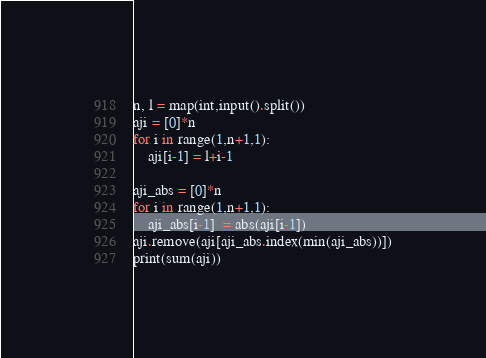Convert code to text. <code><loc_0><loc_0><loc_500><loc_500><_Python_>n, l = map(int,input().split())
aji = [0]*n
for i in range(1,n+1,1):
    aji[i-1] = l+i-1

aji_abs = [0]*n
for i in range(1,n+1,1):
    aji_abs[i-1]  = abs(aji[i-1])
aji.remove(aji[aji_abs.index(min(aji_abs))])
print(sum(aji))
</code> 